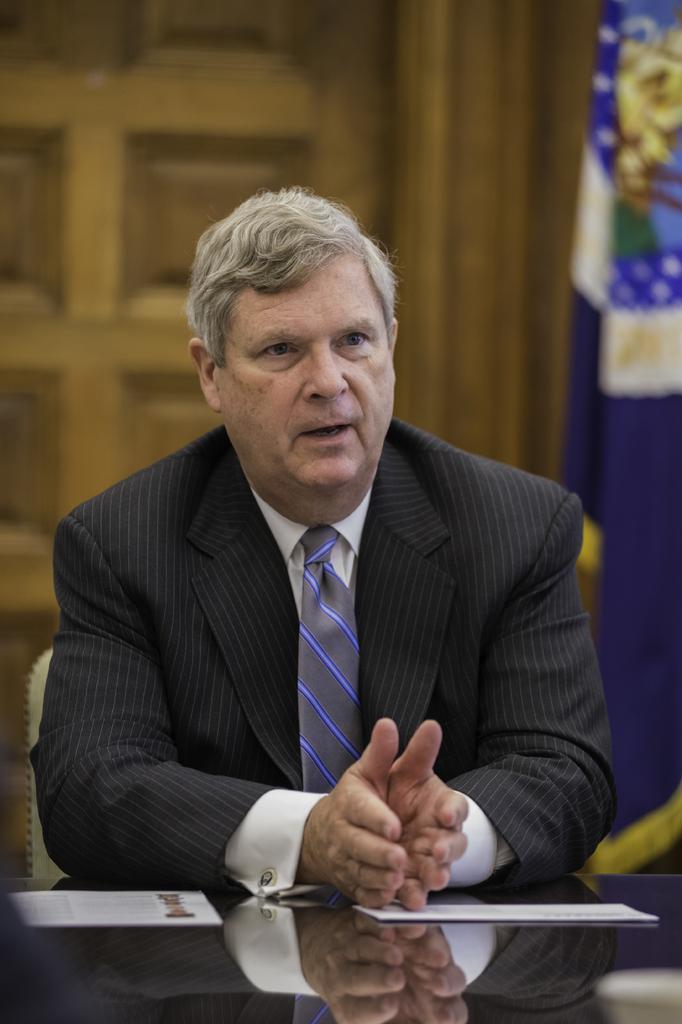Can you describe this image briefly? In the center of the image we can see a man sitting, before him there is a table and we can see papers placed on the table. On the right there is a flag. In the background there is a door. 